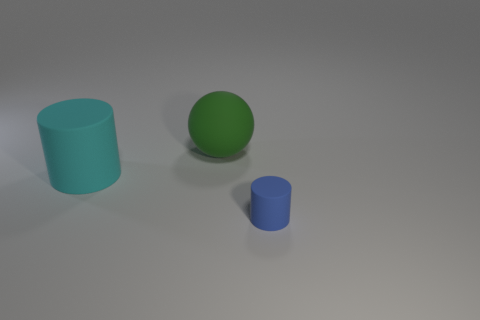What is the shape of the cyan object that is the same size as the green thing? The cyan object that matches the green object in size is a cylinder. It exhibits a circular base with a height that extends vertically from the base, identical in form to a classic cylindrical shape. 